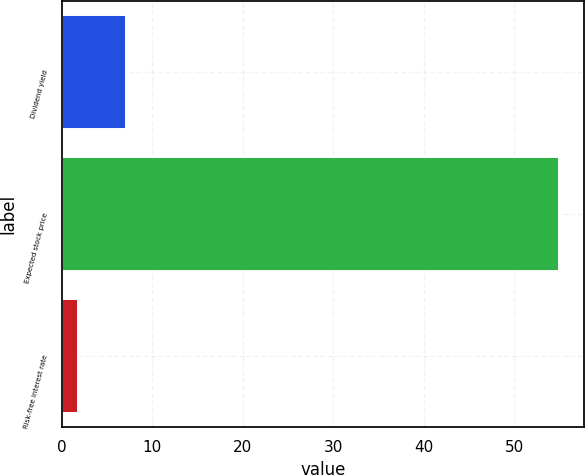<chart> <loc_0><loc_0><loc_500><loc_500><bar_chart><fcel>Dividend yield<fcel>Expected stock price<fcel>Risk-free interest rate<nl><fcel>7.12<fcel>55<fcel>1.8<nl></chart> 